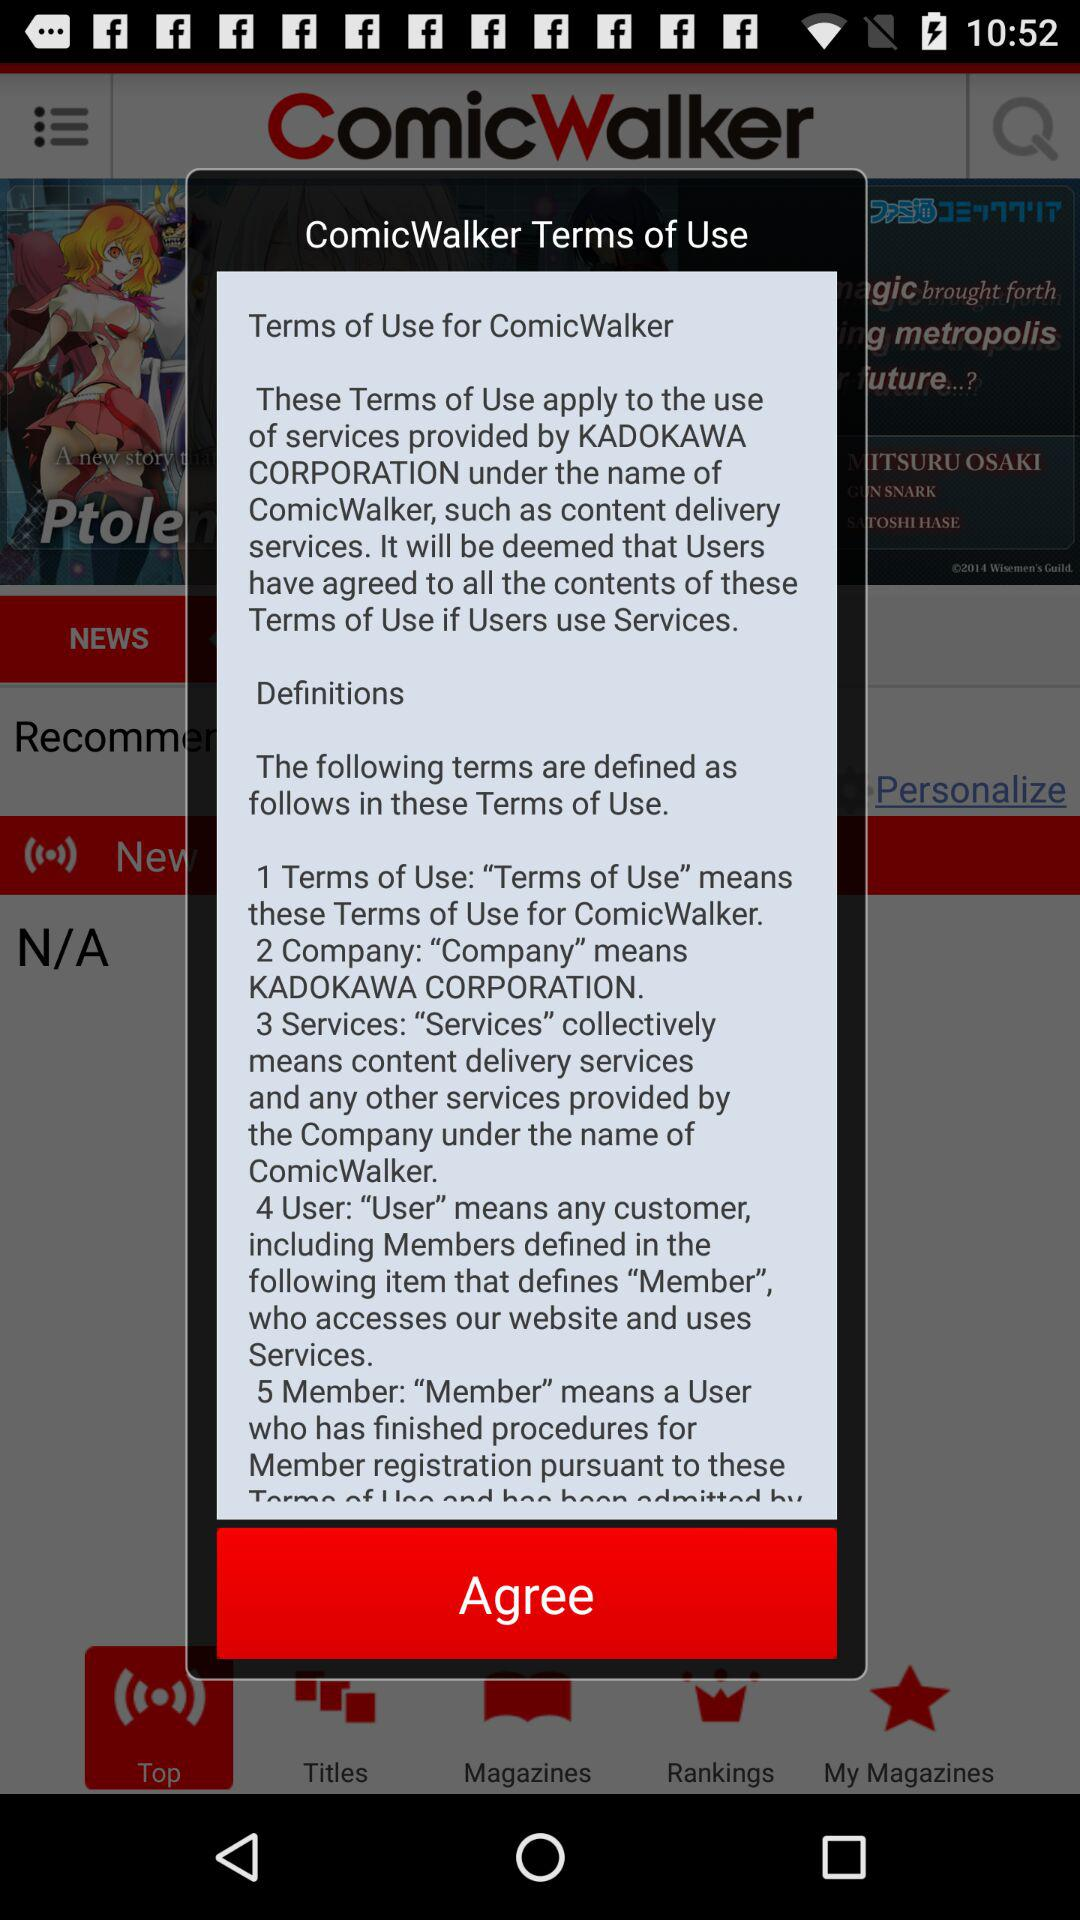How many terms are defined in the Terms of Use?
Answer the question using a single word or phrase. 5 